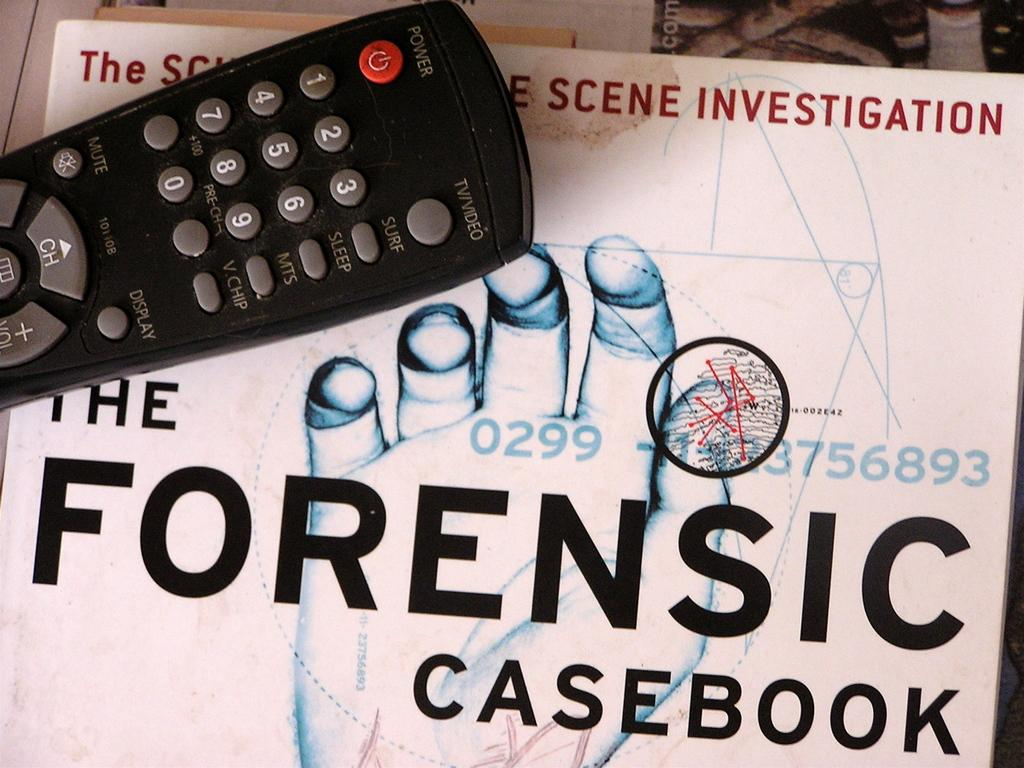<image>
Summarize the visual content of the image. A copy of the Forensic Casebook with a remote on top of it. 